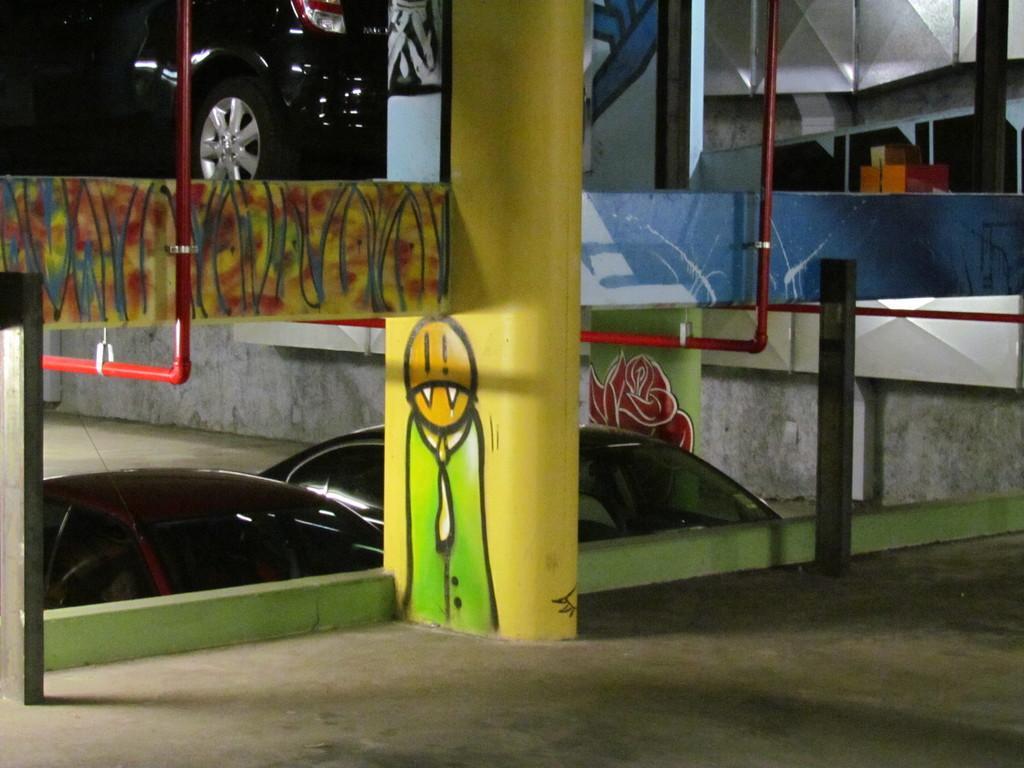Describe this image in one or two sentences. In this picture we can see a pillar in the middle, we can see painting on the pillar, in the background there are some cars, on the left side and right side we can see pipes. 